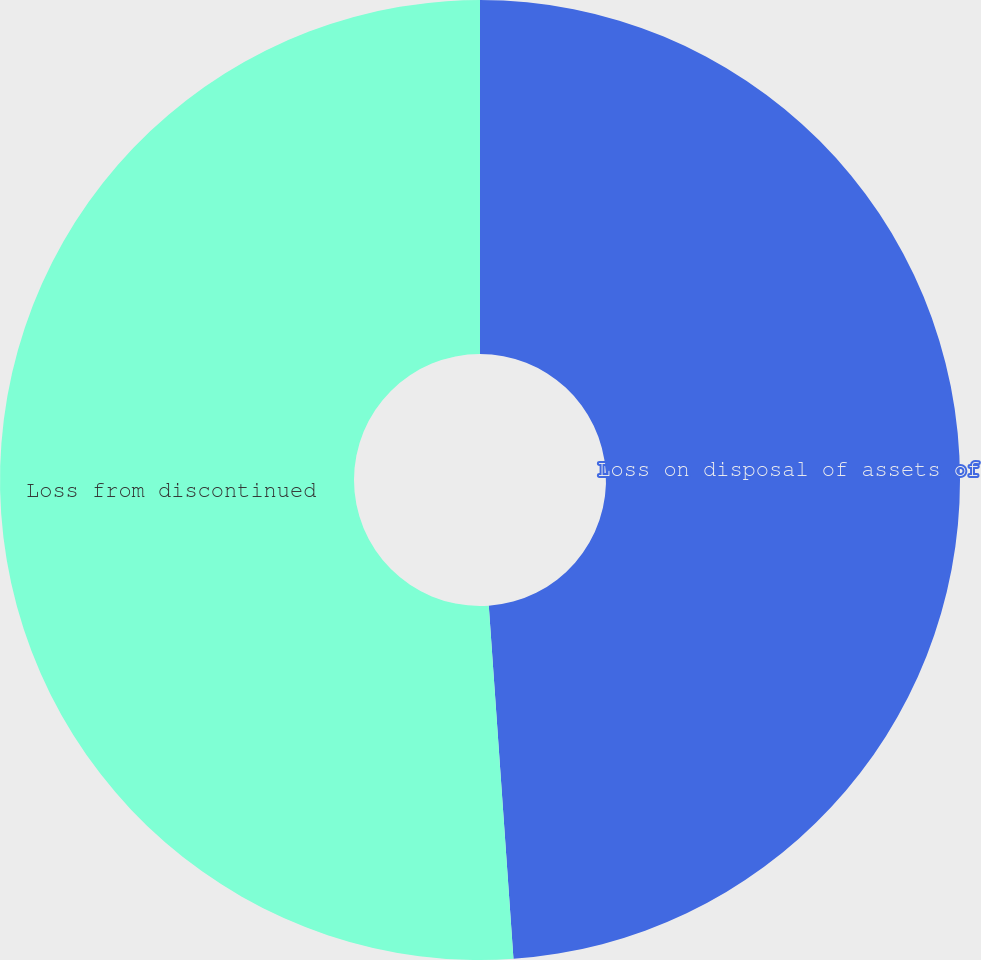Convert chart to OTSL. <chart><loc_0><loc_0><loc_500><loc_500><pie_chart><fcel>Loss on disposal of assets of<fcel>Loss from discontinued<nl><fcel>48.89%<fcel>51.11%<nl></chart> 